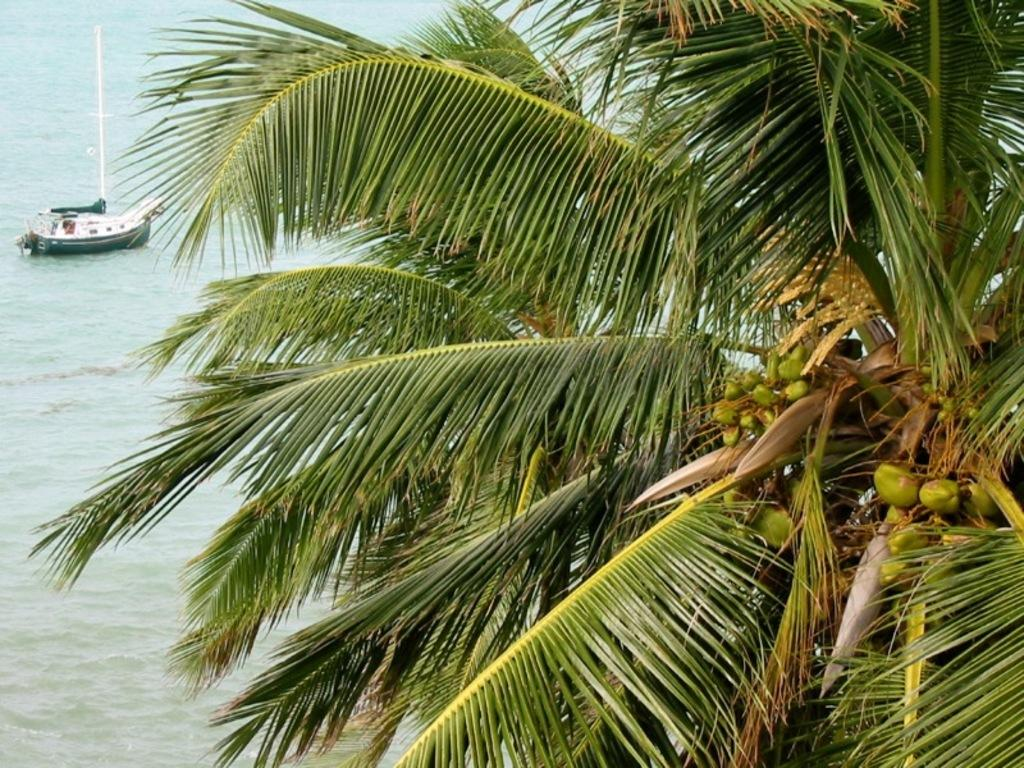What type of tree is in the image? There is a coconut tree in the image. What can be seen in the background of the image? There is a boat visible in the background of the image. What is the boat situated on? The boat is on water. What is the message of the protest happening near the coconut tree in the image? There is no protest present in the image; it only features a coconut tree and a boat in the background. 